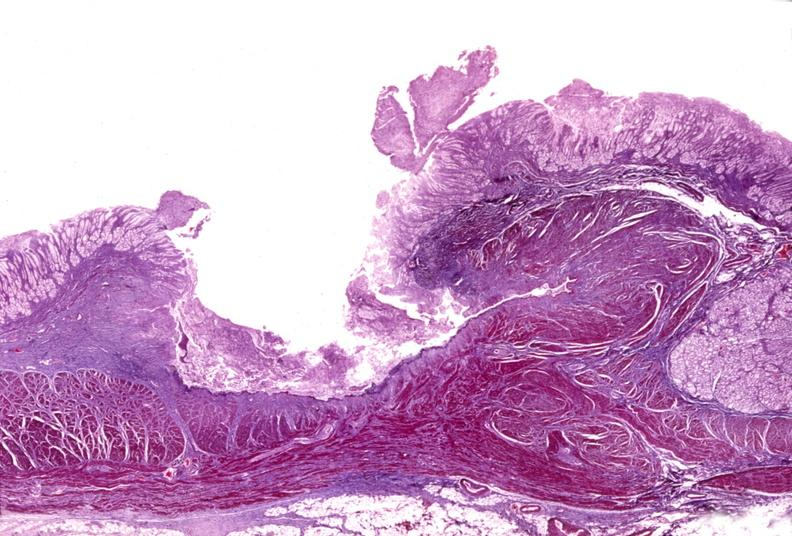what does this image show?
Answer the question using a single word or phrase. Stomach 